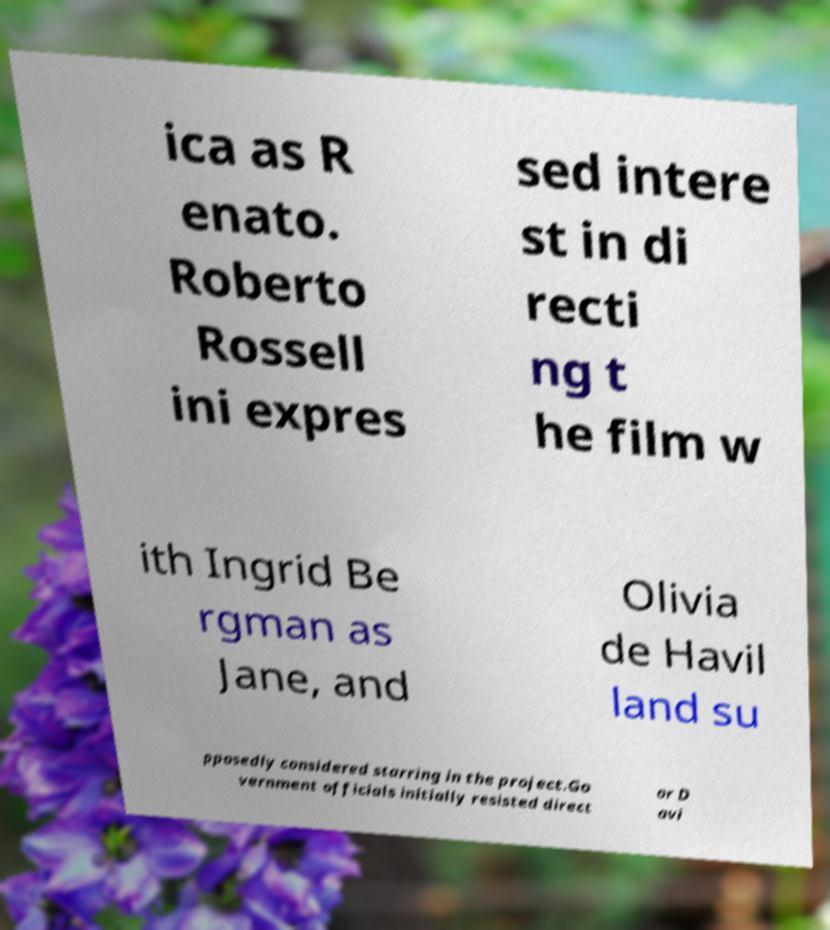I need the written content from this picture converted into text. Can you do that? ica as R enato. Roberto Rossell ini expres sed intere st in di recti ng t he film w ith Ingrid Be rgman as Jane, and Olivia de Havil land su pposedly considered starring in the project.Go vernment officials initially resisted direct or D avi 